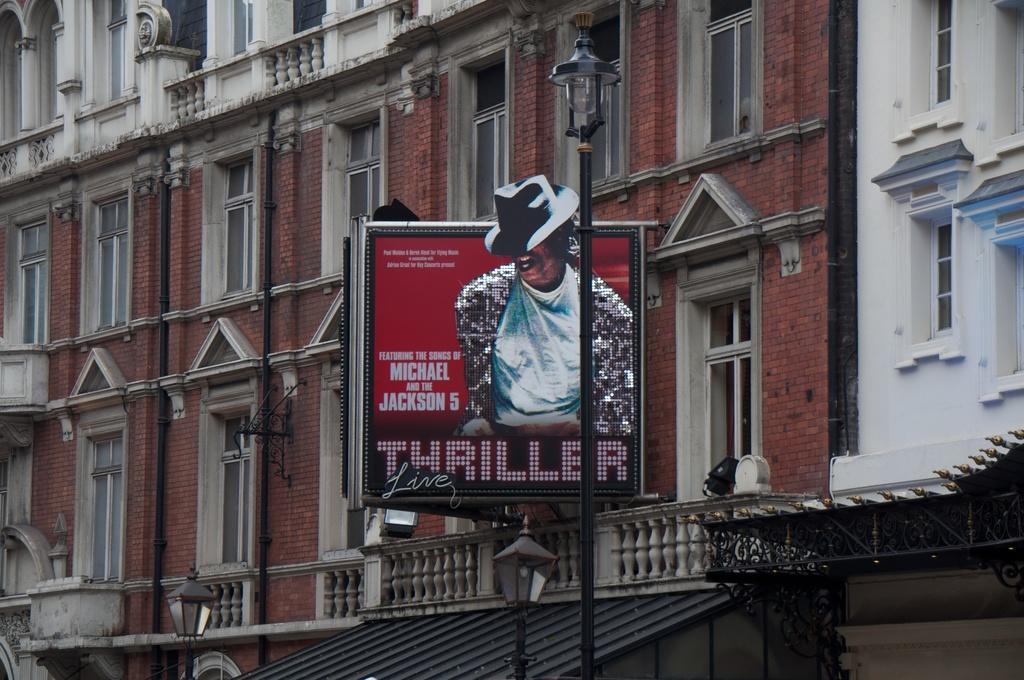Please provide a concise description of this image. In this image, we can see a building and there is a board and we can see some lights. 